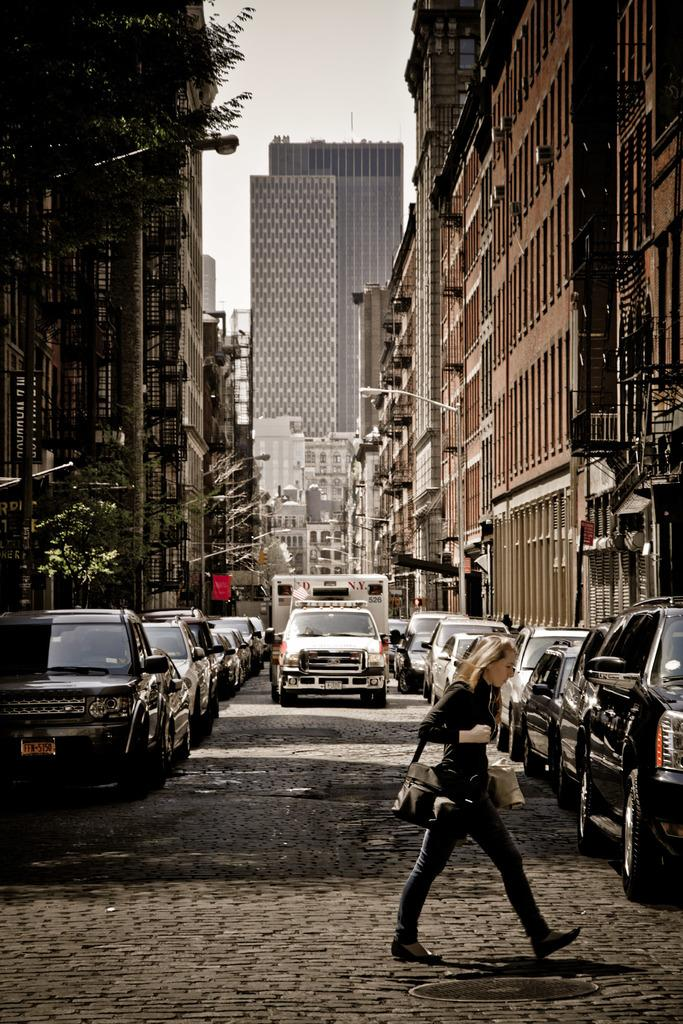<image>
Share a concise interpretation of the image provided. A view down a cobbled urban street with a skyscraper in the background, a woman crossing the road in the foreground and a FD NY van on the road. 